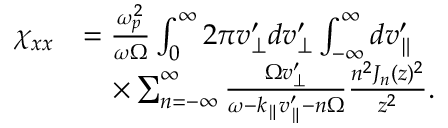Convert formula to latex. <formula><loc_0><loc_0><loc_500><loc_500>\begin{array} { r l } { \chi _ { x x } } & { = \frac { \omega _ { p } ^ { 2 } } { \omega \Omega } \int _ { 0 } ^ { \infty } 2 \pi v _ { \perp } ^ { \prime } d v _ { \perp } ^ { \prime } \int _ { - \infty } ^ { \infty } d v _ { \| } ^ { \prime } } \\ & { \quad \times \sum _ { n = - \infty } ^ { \infty } \frac { \Omega v _ { \perp } ^ { \prime } } { \omega - k _ { \| } v _ { \| } ^ { \prime } - n \Omega } \frac { n ^ { 2 } J _ { n } ( z ) ^ { 2 } } { z ^ { 2 } } . } \end{array}</formula> 